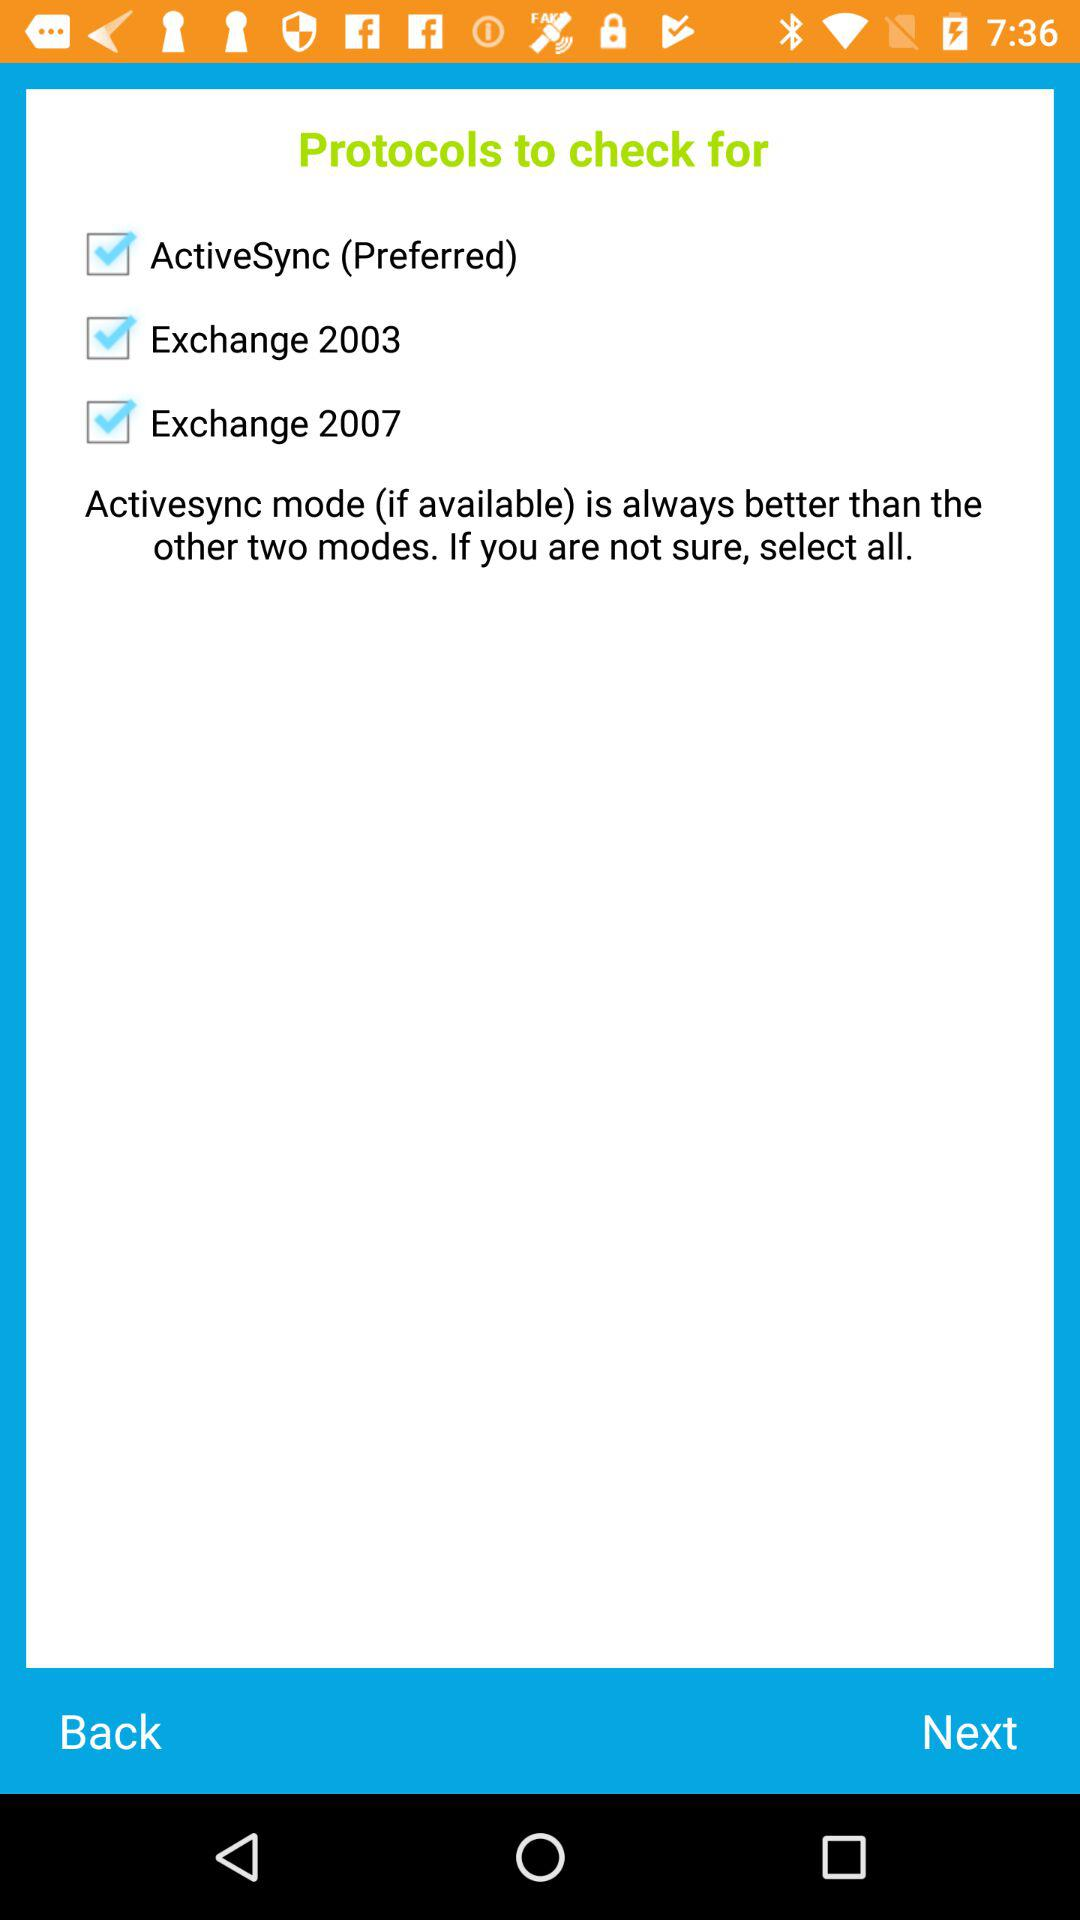What is on the previous page?
When the provided information is insufficient, respond with <no answer>. <no answer> 